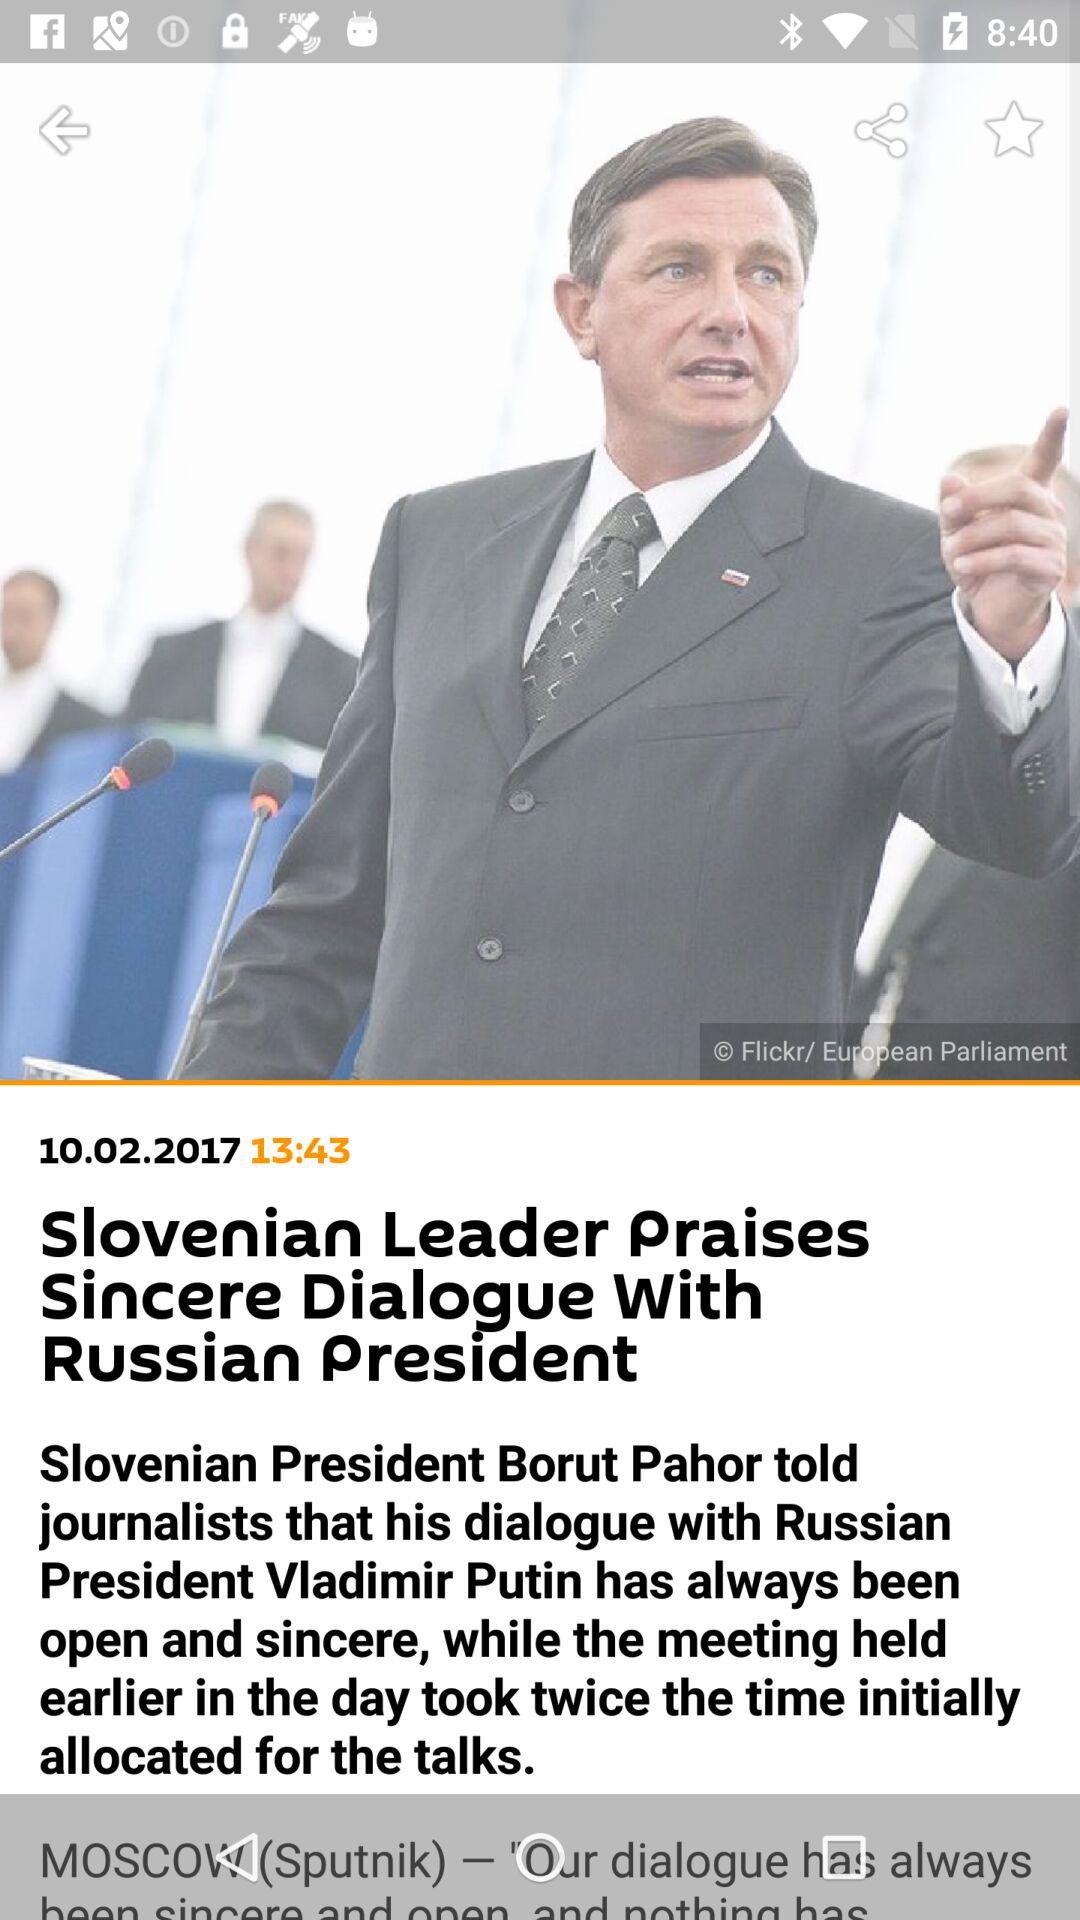What is the title of the news? The title of the news is "Slovenian Leader Praises Sincere Dialogue With Russian President". 